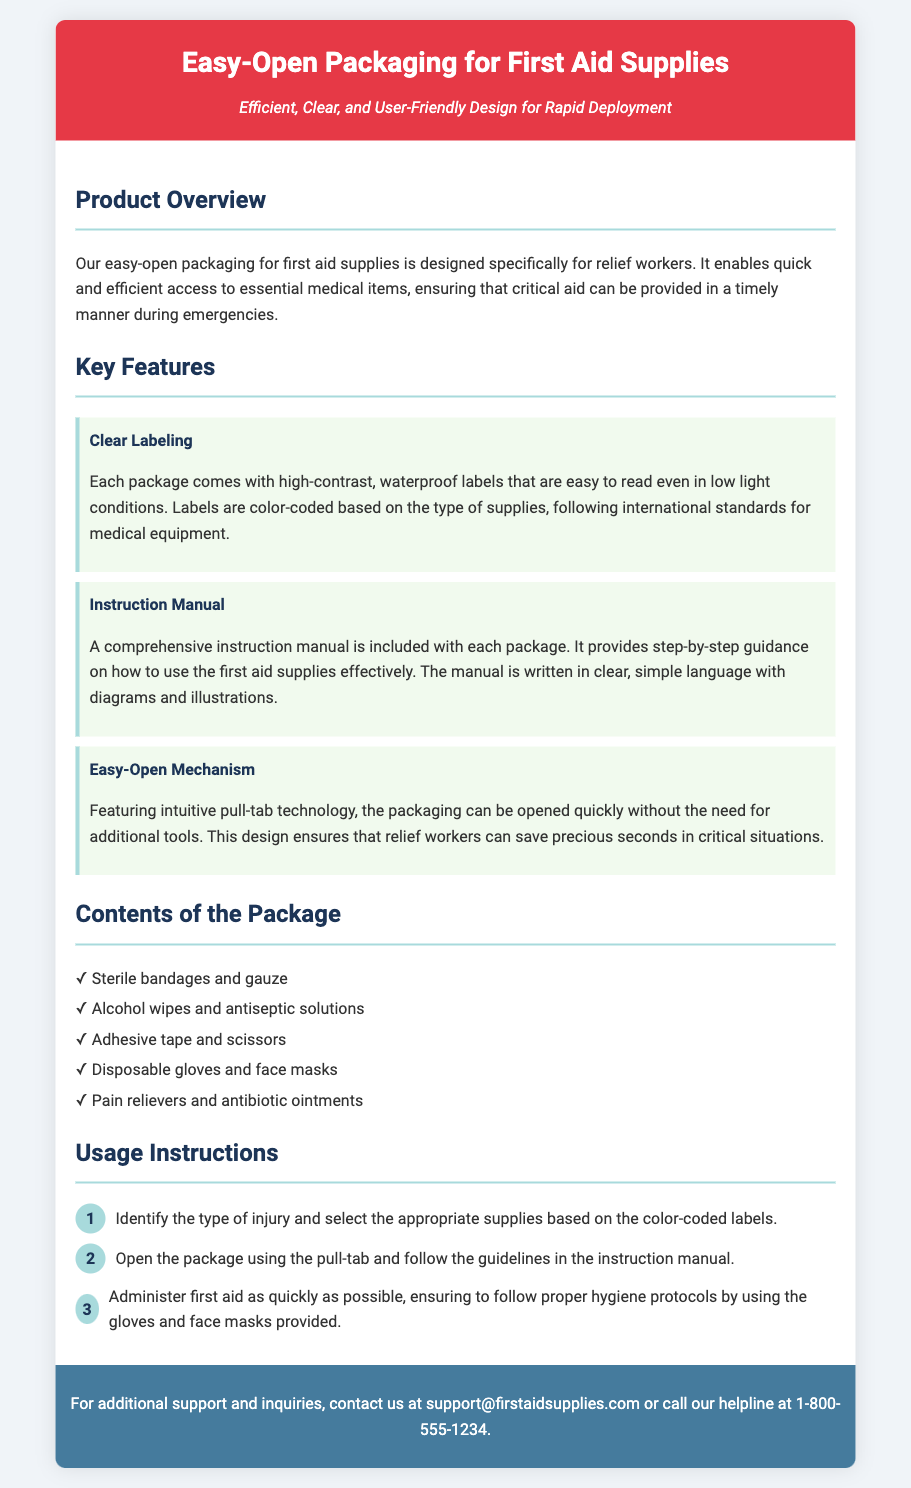What is the product designed for? The product is designed specifically for relief workers to provide essential medical items during emergencies.
Answer: relief workers What type of labels are used on the packaging? The labels are high-contrast, waterproof labels that are also color-coded based on the type of supplies.
Answer: high-contrast waterproof labels What does the instruction manual include? The instruction manual provides step-by-step guidance on how to use the first aid supplies effectively, including diagrams and illustrations.
Answer: step-by-step guidance What technology does the packaging feature for opening? The packaging features intuitive pull-tab technology for quick opening.
Answer: pull-tab technology How many steps are in the usage instructions? The usage instructions consist of three steps provided in the document.
Answer: three steps What types of supplies are included in the package? The package includes items such as sterile bandages, alcohol wipes, and disposable gloves.
Answer: sterile bandages, alcohol wipes, disposable gloves What is the color of the header background? The header background is colored in a shade that matches the brand identity of the product.
Answer: red How can additional support be contacted? Additional support can be contacted via email or phone, as detailed in the contact section.
Answer: email or phone What is emphasized in the product's design? The design emphasizes clear, user-friendly functionalities for rapid deployment by relief workers.
Answer: clarity and user-friendliness 